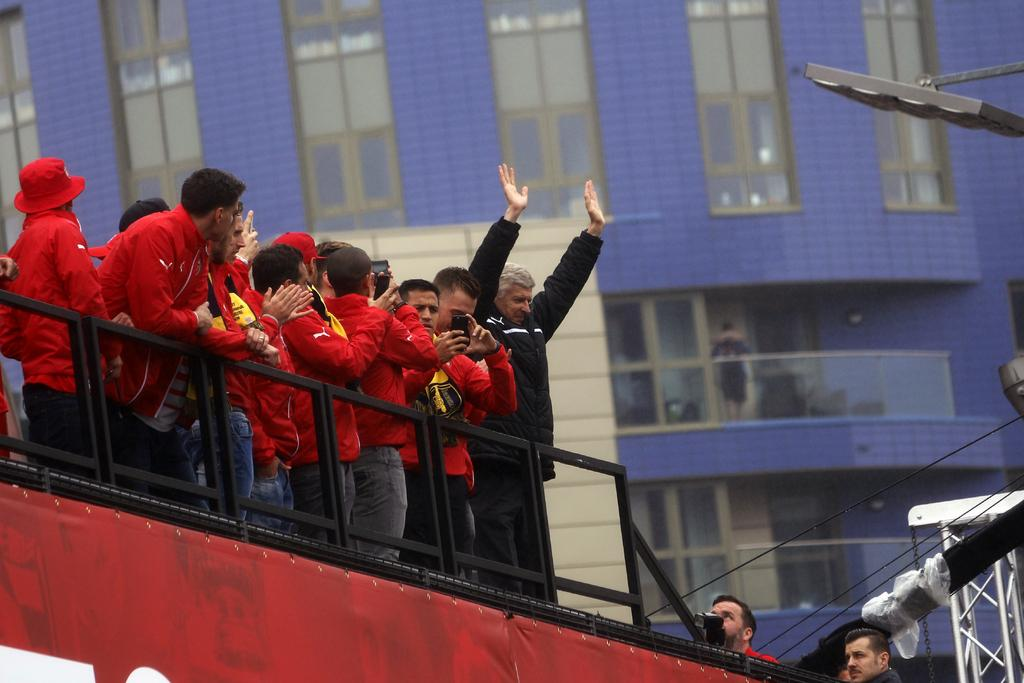What are the people in the image doing? The people in the image are standing on a vehicle. What can be seen in the background of the image? There is a building with windows in the background of the image. What type of drink is being passed around among the people on the vehicle? There is no drink visible in the image, and it is not mentioned in the provided facts. 